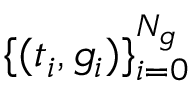<formula> <loc_0><loc_0><loc_500><loc_500>\{ ( t _ { i } , g _ { i } ) \} _ { i = 0 } ^ { N _ { g } }</formula> 